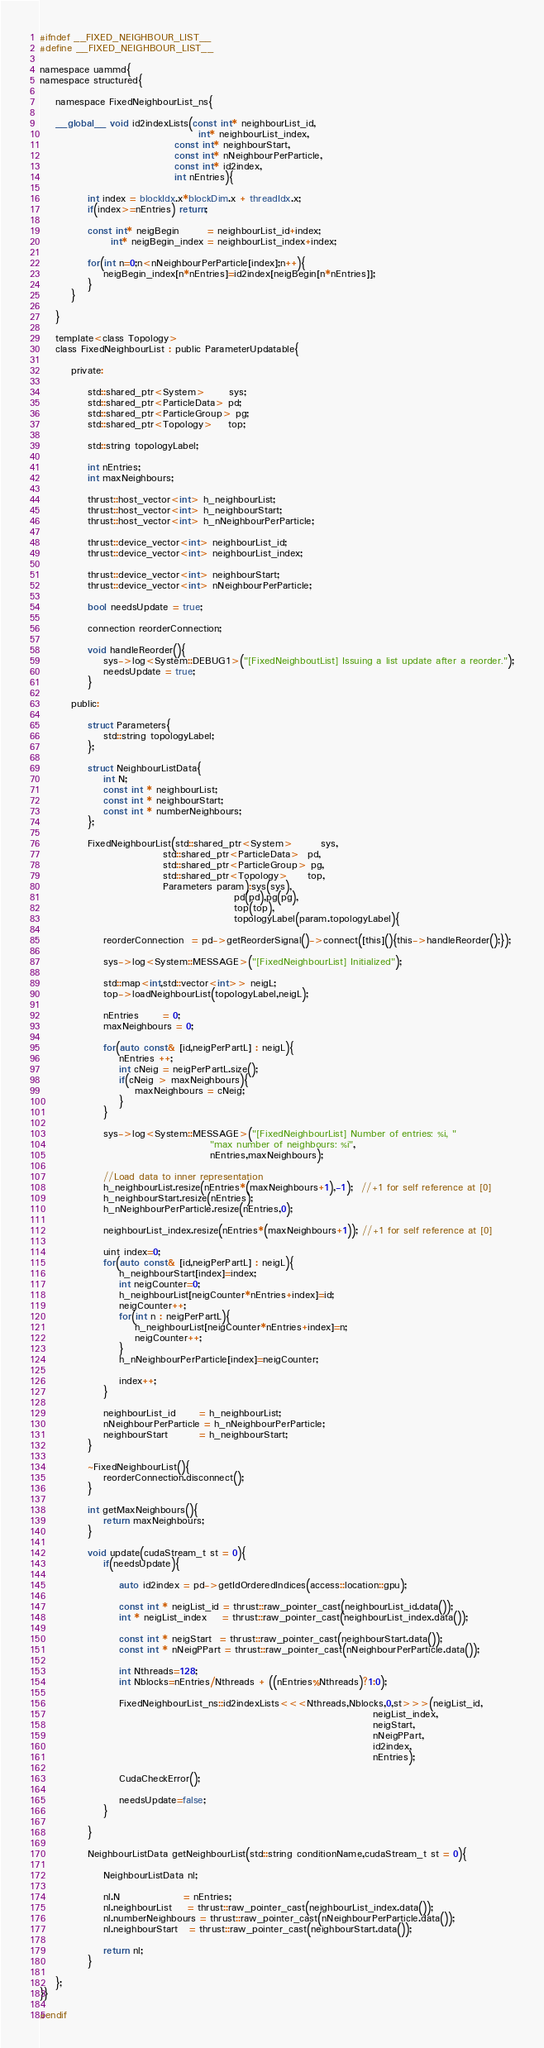Convert code to text. <code><loc_0><loc_0><loc_500><loc_500><_Cuda_>#ifndef __FIXED_NEIGHBOUR_LIST__
#define __FIXED_NEIGHBOUR_LIST__

namespace uammd{
namespace structured{
  
    namespace FixedNeighbourList_ns{
    
    __global__ void id2indexLists(const int* neighbourList_id,
                                        int* neighbourList_index,
                                  const int* neighbourStart,
                                  const int* nNeighbourPerParticle,
                                  const int* id2index,
                                  int nEntries){
            
            int index = blockIdx.x*blockDim.x + threadIdx.x;
            if(index>=nEntries) return;

            const int* neigBegin       = neighbourList_id+index;
                  int* neigBegin_index = neighbourList_index+index;

            for(int n=0;n<nNeighbourPerParticle[index];n++){
                neigBegin_index[n*nEntries]=id2index[neigBegin[n*nEntries]];
            }
        }
    
    }
    
    template<class Topology>
    class FixedNeighbourList : public ParameterUpdatable{

        private:
            
            std::shared_ptr<System>      sys;
            std::shared_ptr<ParticleData> pd;
            std::shared_ptr<ParticleGroup> pg;
            std::shared_ptr<Topology>    top;           
                
            std::string topologyLabel;

            int nEntries;
            int maxNeighbours;

            thrust::host_vector<int> h_neighbourList;
            thrust::host_vector<int> h_neighbourStart;
            thrust::host_vector<int> h_nNeighbourPerParticle;
            
            thrust::device_vector<int> neighbourList_id;
            thrust::device_vector<int> neighbourList_index;
            
            thrust::device_vector<int> neighbourStart;
            thrust::device_vector<int> nNeighbourPerParticle;
         
            bool needsUpdate = true;

            connection reorderConnection;
          
            void handleReorder(){
                sys->log<System::DEBUG1>("[FixedNeighboutList] Issuing a list update after a reorder.");
                needsUpdate = true;
            }

        public:
            
            struct Parameters{
                std::string topologyLabel;
            };
            
            struct NeighbourListData{
                int N;
                const int * neighbourList;
                const int * neighbourStart;
                const int * numberNeighbours;
            };

            FixedNeighbourList(std::shared_ptr<System>       sys,
                               std::shared_ptr<ParticleData>  pd,
                               std::shared_ptr<ParticleGroup> pg,
                               std::shared_ptr<Topology>     top,
                               Parameters param):sys(sys),
                                                 pd(pd),pg(pg),
                                                 top(top),
                                                 topologyLabel(param.topologyLabel){
              
                reorderConnection  = pd->getReorderSignal()->connect([this](){this->handleReorder();});

                sys->log<System::MESSAGE>("[FixedNeighbourList] Initialized");
                
                std::map<int,std::vector<int>> neigL;
                top->loadNeighbourList(topologyLabel,neigL);
                
                nEntries      = 0;
                maxNeighbours = 0;

                for(auto const& [id,neigPerPartL] : neigL){
                    nEntries ++;
                    int cNeig = neigPerPartL.size();
                    if(cNeig > maxNeighbours){
                        maxNeighbours = cNeig;
                    }
                }
                
                sys->log<System::MESSAGE>("[FixedNeighbourList] Number of entries: %i, "
                                           "max number of neighbours: %i",
                                           nEntries,maxNeighbours);
                
                //Load data to inner representation
                h_neighbourList.resize(nEntries*(maxNeighbours+1),-1);  //+1 for self reference at [0]
                h_neighbourStart.resize(nEntries);
                h_nNeighbourPerParticle.resize(nEntries,0);
            
                neighbourList_index.resize(nEntries*(maxNeighbours+1)); //+1 for self reference at [0]
                
                uint index=0;
                for(auto const& [id,neigPerPartL] : neigL){
                    h_neighbourStart[index]=index;
                    int neigCounter=0;
                    h_neighbourList[neigCounter*nEntries+index]=id;
                    neigCounter++;
                    for(int n : neigPerPartL){
                        h_neighbourList[neigCounter*nEntries+index]=n;
                        neigCounter++;
                    }
                    h_nNeighbourPerParticle[index]=neigCounter;

                    index++;
                }
                    
                neighbourList_id      = h_neighbourList;
                nNeighbourPerParticle = h_nNeighbourPerParticle;
                neighbourStart        = h_neighbourStart;
            }
          
            ~FixedNeighbourList(){
                reorderConnection.disconnect();
            }

            int getMaxNeighbours(){
                return maxNeighbours;
            }

            void update(cudaStream_t st = 0){
                if(needsUpdate){
                    
                    auto id2index = pd->getIdOrderedIndices(access::location::gpu);

                    const int * neigList_id = thrust::raw_pointer_cast(neighbourList_id.data());
                    int * neigList_index    = thrust::raw_pointer_cast(neighbourList_index.data());
                    
                    const int * neigStart  = thrust::raw_pointer_cast(neighbourStart.data());
                    const int * nNeigPPart = thrust::raw_pointer_cast(nNeighbourPerParticle.data());
                    
                    int Nthreads=128;
                    int Nblocks=nEntries/Nthreads + ((nEntries%Nthreads)?1:0);

                    FixedNeighbourList_ns::id2indexLists<<<Nthreads,Nblocks,0,st>>>(neigList_id,
                                                                                    neigList_index,
                                                                                    neigStart,
                                                                                    nNeigPPart,
                                                                                    id2index,
                                                                                    nEntries);
                    
                    CudaCheckError();

                    needsUpdate=false;
                }

            }
            
            NeighbourListData getNeighbourList(std::string conditionName,cudaStream_t st = 0){
                
                NeighbourListData nl;
                    
                nl.N                = nEntries; 
                nl.neighbourList    = thrust::raw_pointer_cast(neighbourList_index.data());
                nl.numberNeighbours = thrust::raw_pointer_cast(nNeighbourPerParticle.data());
                nl.neighbourStart   = thrust::raw_pointer_cast(neighbourStart.data());
                
                return nl;
            }

    };
}}

#endif
</code> 